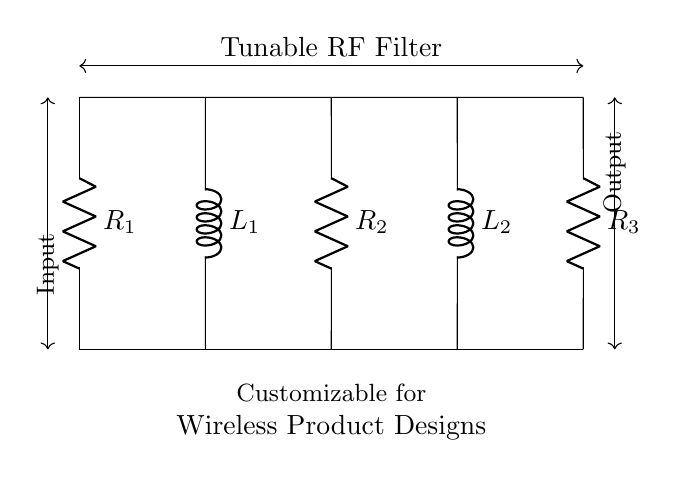What are the components in this circuit? The circuit includes resistors R1, R2, R3 and inductors L1, L2. These components can be seen in the diagram, and their labels are indicated next to them.
Answer: resistors R1, R2, R3 and inductors L1, L2 What is the role of the inductors in this circuit? Inductors in this circuit are used to create a tunable RF filter, which allows for frequency selectivity in wireless designs. They influence the circuit's impedance and resonant frequency.
Answer: frequency selectivity How many resistors are present in the circuit? There are three resistors, which are labeled R1, R2, and R3. They can be counted directly from the diagram.
Answer: three What is the configuration of the resistors and inductors? The circuit has resistors and inductors arranged in series, alternating between the two types. This pattern is evident from the shown connections and labels in the circuit diagram.
Answer: series alternating How is the tunability of the RF filter achieved in this circuit? Tunability is achieved by varying the values of the inductors and/or resistors, which influences the cutoff frequency and response of the filter. The diagram indicates that component values can be adjusted for customization.
Answer: varying component values What is the expected input and output of the circuit? The input comes from the left side and the output is taken from the right side of the circuit, as indicated by the labeled arrows showing the direction of current flow.
Answer: left input, right output What effect does increasing R1 have on the circuit performance? Increasing R1 will increase the total resistance in the circuit, which can lower the current flow and affect the filter’s response, potentially widening the bandwidth or altering the cutoff frequency.
Answer: increases total resistance 